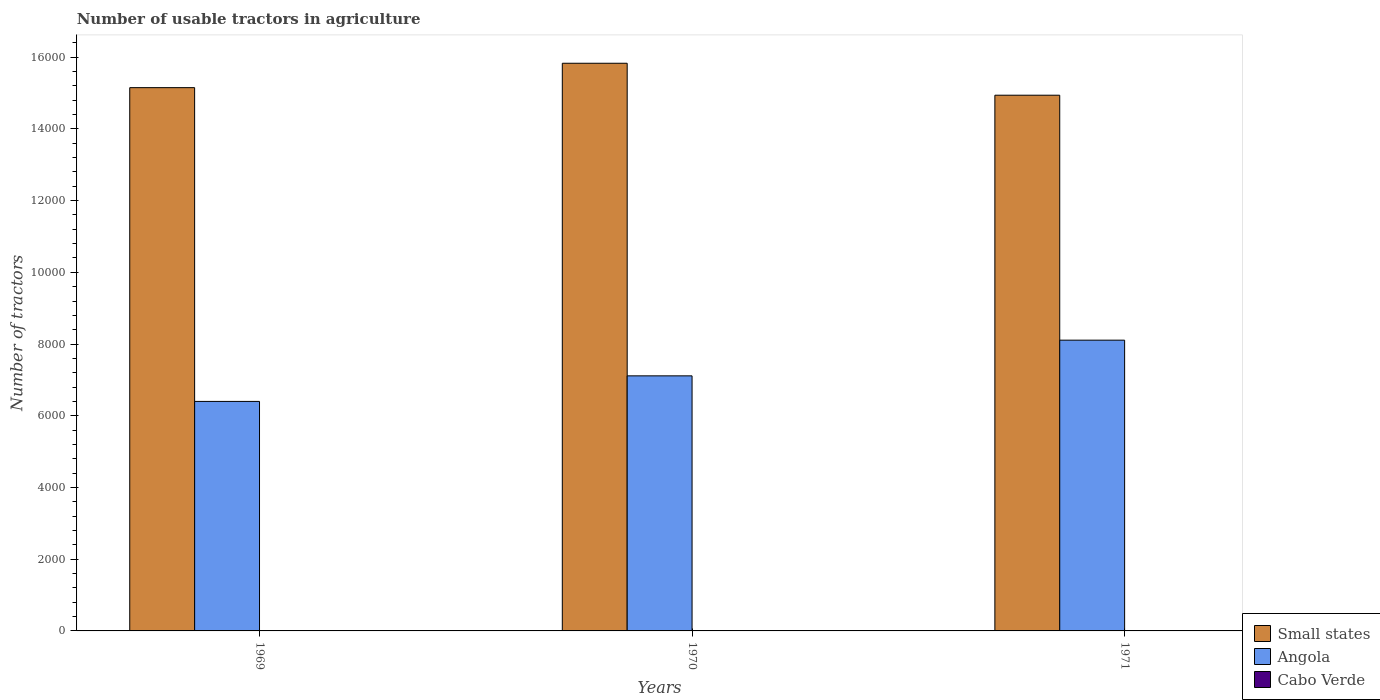How many groups of bars are there?
Keep it short and to the point. 3. Are the number of bars per tick equal to the number of legend labels?
Give a very brief answer. Yes. What is the label of the 1st group of bars from the left?
Your answer should be very brief. 1969. What is the number of usable tractors in agriculture in Angola in 1970?
Offer a terse response. 7113. Across all years, what is the maximum number of usable tractors in agriculture in Angola?
Offer a very short reply. 8108. Across all years, what is the minimum number of usable tractors in agriculture in Cabo Verde?
Ensure brevity in your answer.  5. In which year was the number of usable tractors in agriculture in Angola maximum?
Provide a short and direct response. 1971. In which year was the number of usable tractors in agriculture in Angola minimum?
Provide a short and direct response. 1969. What is the total number of usable tractors in agriculture in Small states in the graph?
Your response must be concise. 4.59e+04. What is the difference between the number of usable tractors in agriculture in Small states in 1969 and that in 1970?
Your answer should be very brief. -680. What is the difference between the number of usable tractors in agriculture in Angola in 1969 and the number of usable tractors in agriculture in Small states in 1971?
Provide a short and direct response. -8539. What is the average number of usable tractors in agriculture in Small states per year?
Offer a very short reply. 1.53e+04. In the year 1969, what is the difference between the number of usable tractors in agriculture in Cabo Verde and number of usable tractors in agriculture in Angola?
Provide a succinct answer. -6395. What is the ratio of the number of usable tractors in agriculture in Cabo Verde in 1970 to that in 1971?
Make the answer very short. 0.83. What is the difference between the highest and the second highest number of usable tractors in agriculture in Cabo Verde?
Your answer should be compact. 1. What is the difference between the highest and the lowest number of usable tractors in agriculture in Small states?
Offer a terse response. 891. What does the 1st bar from the left in 1969 represents?
Offer a terse response. Small states. What does the 1st bar from the right in 1971 represents?
Your response must be concise. Cabo Verde. How many bars are there?
Make the answer very short. 9. Are all the bars in the graph horizontal?
Give a very brief answer. No. How many years are there in the graph?
Offer a terse response. 3. Are the values on the major ticks of Y-axis written in scientific E-notation?
Your answer should be very brief. No. Does the graph contain grids?
Your answer should be very brief. No. Where does the legend appear in the graph?
Keep it short and to the point. Bottom right. How many legend labels are there?
Offer a very short reply. 3. What is the title of the graph?
Your answer should be very brief. Number of usable tractors in agriculture. Does "Turks and Caicos Islands" appear as one of the legend labels in the graph?
Ensure brevity in your answer.  No. What is the label or title of the X-axis?
Offer a terse response. Years. What is the label or title of the Y-axis?
Offer a very short reply. Number of tractors. What is the Number of tractors in Small states in 1969?
Your answer should be compact. 1.52e+04. What is the Number of tractors in Angola in 1969?
Ensure brevity in your answer.  6400. What is the Number of tractors in Cabo Verde in 1969?
Keep it short and to the point. 5. What is the Number of tractors in Small states in 1970?
Keep it short and to the point. 1.58e+04. What is the Number of tractors in Angola in 1970?
Offer a terse response. 7113. What is the Number of tractors in Cabo Verde in 1970?
Your answer should be compact. 5. What is the Number of tractors of Small states in 1971?
Make the answer very short. 1.49e+04. What is the Number of tractors of Angola in 1971?
Your answer should be compact. 8108. What is the Number of tractors in Cabo Verde in 1971?
Keep it short and to the point. 6. Across all years, what is the maximum Number of tractors in Small states?
Offer a terse response. 1.58e+04. Across all years, what is the maximum Number of tractors in Angola?
Make the answer very short. 8108. Across all years, what is the minimum Number of tractors of Small states?
Your answer should be very brief. 1.49e+04. Across all years, what is the minimum Number of tractors in Angola?
Provide a succinct answer. 6400. What is the total Number of tractors of Small states in the graph?
Provide a succinct answer. 4.59e+04. What is the total Number of tractors in Angola in the graph?
Your response must be concise. 2.16e+04. What is the difference between the Number of tractors in Small states in 1969 and that in 1970?
Offer a very short reply. -680. What is the difference between the Number of tractors in Angola in 1969 and that in 1970?
Your answer should be compact. -713. What is the difference between the Number of tractors of Small states in 1969 and that in 1971?
Provide a short and direct response. 211. What is the difference between the Number of tractors of Angola in 1969 and that in 1971?
Your answer should be very brief. -1708. What is the difference between the Number of tractors of Small states in 1970 and that in 1971?
Provide a succinct answer. 891. What is the difference between the Number of tractors of Angola in 1970 and that in 1971?
Provide a short and direct response. -995. What is the difference between the Number of tractors in Small states in 1969 and the Number of tractors in Angola in 1970?
Provide a succinct answer. 8037. What is the difference between the Number of tractors in Small states in 1969 and the Number of tractors in Cabo Verde in 1970?
Ensure brevity in your answer.  1.51e+04. What is the difference between the Number of tractors in Angola in 1969 and the Number of tractors in Cabo Verde in 1970?
Give a very brief answer. 6395. What is the difference between the Number of tractors in Small states in 1969 and the Number of tractors in Angola in 1971?
Offer a very short reply. 7042. What is the difference between the Number of tractors of Small states in 1969 and the Number of tractors of Cabo Verde in 1971?
Provide a short and direct response. 1.51e+04. What is the difference between the Number of tractors of Angola in 1969 and the Number of tractors of Cabo Verde in 1971?
Your answer should be very brief. 6394. What is the difference between the Number of tractors of Small states in 1970 and the Number of tractors of Angola in 1971?
Offer a very short reply. 7722. What is the difference between the Number of tractors of Small states in 1970 and the Number of tractors of Cabo Verde in 1971?
Your answer should be very brief. 1.58e+04. What is the difference between the Number of tractors of Angola in 1970 and the Number of tractors of Cabo Verde in 1971?
Provide a succinct answer. 7107. What is the average Number of tractors in Small states per year?
Your answer should be compact. 1.53e+04. What is the average Number of tractors in Angola per year?
Keep it short and to the point. 7207. What is the average Number of tractors of Cabo Verde per year?
Offer a very short reply. 5.33. In the year 1969, what is the difference between the Number of tractors of Small states and Number of tractors of Angola?
Offer a very short reply. 8750. In the year 1969, what is the difference between the Number of tractors of Small states and Number of tractors of Cabo Verde?
Provide a succinct answer. 1.51e+04. In the year 1969, what is the difference between the Number of tractors of Angola and Number of tractors of Cabo Verde?
Offer a very short reply. 6395. In the year 1970, what is the difference between the Number of tractors of Small states and Number of tractors of Angola?
Make the answer very short. 8717. In the year 1970, what is the difference between the Number of tractors of Small states and Number of tractors of Cabo Verde?
Your response must be concise. 1.58e+04. In the year 1970, what is the difference between the Number of tractors of Angola and Number of tractors of Cabo Verde?
Ensure brevity in your answer.  7108. In the year 1971, what is the difference between the Number of tractors of Small states and Number of tractors of Angola?
Offer a very short reply. 6831. In the year 1971, what is the difference between the Number of tractors of Small states and Number of tractors of Cabo Verde?
Offer a very short reply. 1.49e+04. In the year 1971, what is the difference between the Number of tractors in Angola and Number of tractors in Cabo Verde?
Make the answer very short. 8102. What is the ratio of the Number of tractors of Angola in 1969 to that in 1970?
Offer a very short reply. 0.9. What is the ratio of the Number of tractors of Cabo Verde in 1969 to that in 1970?
Your answer should be compact. 1. What is the ratio of the Number of tractors in Small states in 1969 to that in 1971?
Ensure brevity in your answer.  1.01. What is the ratio of the Number of tractors of Angola in 1969 to that in 1971?
Provide a succinct answer. 0.79. What is the ratio of the Number of tractors in Small states in 1970 to that in 1971?
Keep it short and to the point. 1.06. What is the ratio of the Number of tractors of Angola in 1970 to that in 1971?
Offer a terse response. 0.88. What is the difference between the highest and the second highest Number of tractors of Small states?
Offer a terse response. 680. What is the difference between the highest and the second highest Number of tractors of Angola?
Offer a terse response. 995. What is the difference between the highest and the second highest Number of tractors in Cabo Verde?
Keep it short and to the point. 1. What is the difference between the highest and the lowest Number of tractors of Small states?
Your answer should be compact. 891. What is the difference between the highest and the lowest Number of tractors in Angola?
Your response must be concise. 1708. 